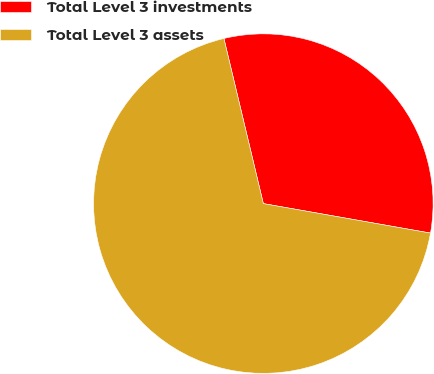<chart> <loc_0><loc_0><loc_500><loc_500><pie_chart><fcel>Total Level 3 investments<fcel>Total Level 3 assets<nl><fcel>31.51%<fcel>68.49%<nl></chart> 